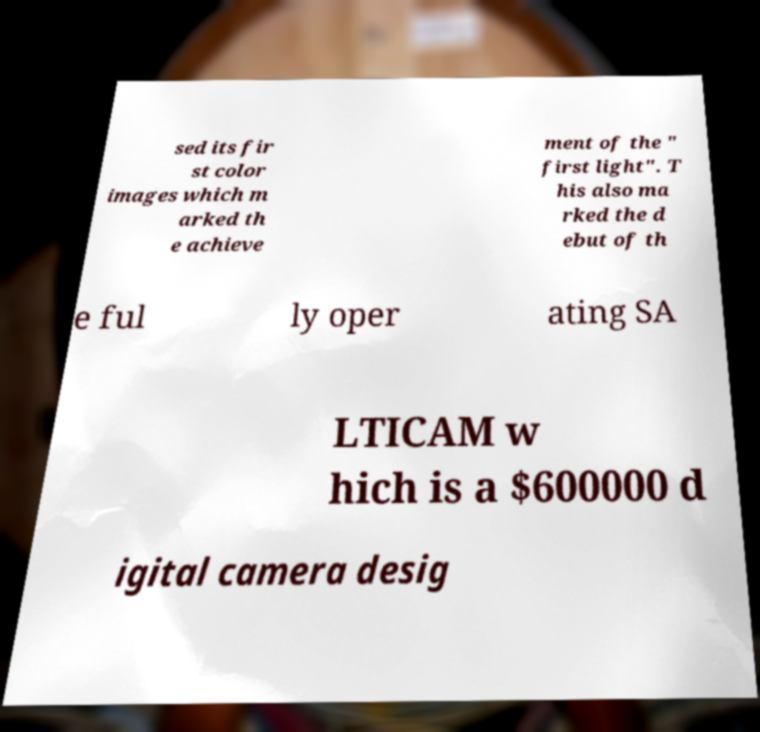What messages or text are displayed in this image? I need them in a readable, typed format. sed its fir st color images which m arked th e achieve ment of the " first light". T his also ma rked the d ebut of th e ful ly oper ating SA LTICAM w hich is a $600000 d igital camera desig 